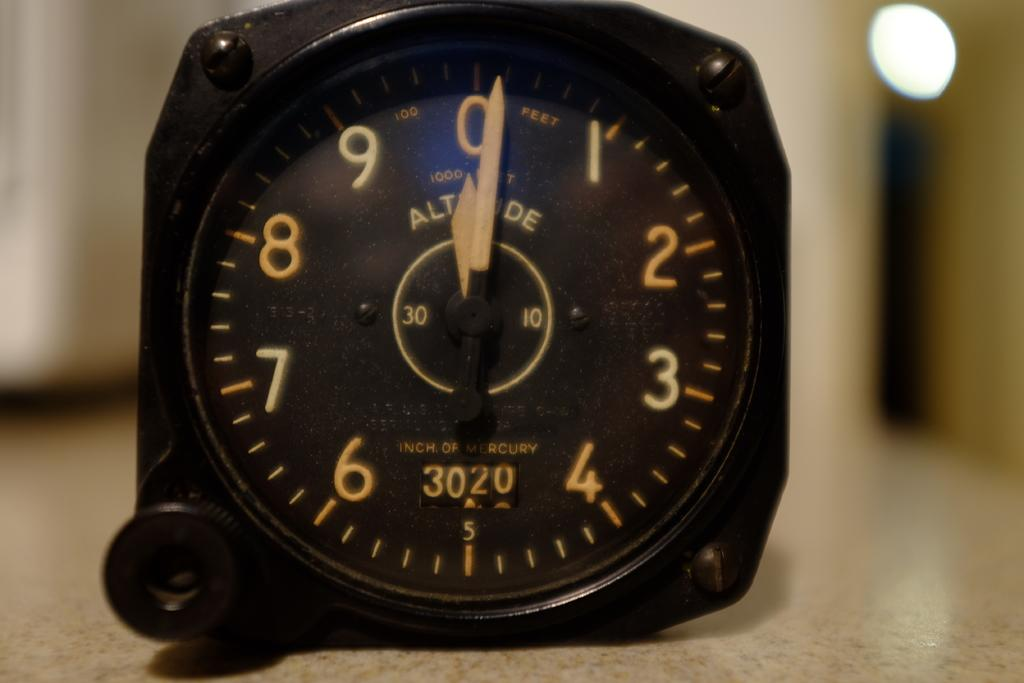What is the main object in the image? There is a clock dial in the image. Where is the clock dial located? The clock dial is placed on a concrete surface. Can you touch the yoke in the image? There is no yoke present in the image, so it cannot be touched. 